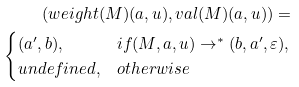Convert formula to latex. <formula><loc_0><loc_0><loc_500><loc_500>( w e i g h t ( M ) ( a , u ) , v a l ( M ) ( a , u ) ) = \\ \begin{cases} ( a ^ { \prime } , b ) , & i f ( M , a , u ) \to ^ { \ast } ( b , a ^ { \prime } , \varepsilon ) , \\ u n d e f i n e d , & o t h e r w i s e \end{cases}</formula> 